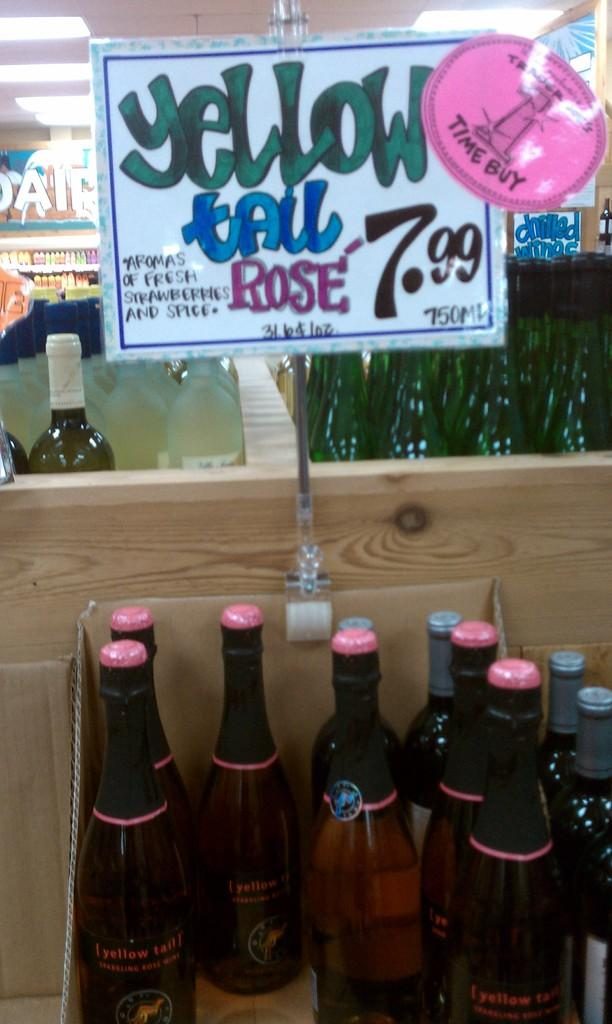<image>
Create a compact narrative representing the image presented. A sign advertises a sale for Yellow Tail wine, priced at $7.99 